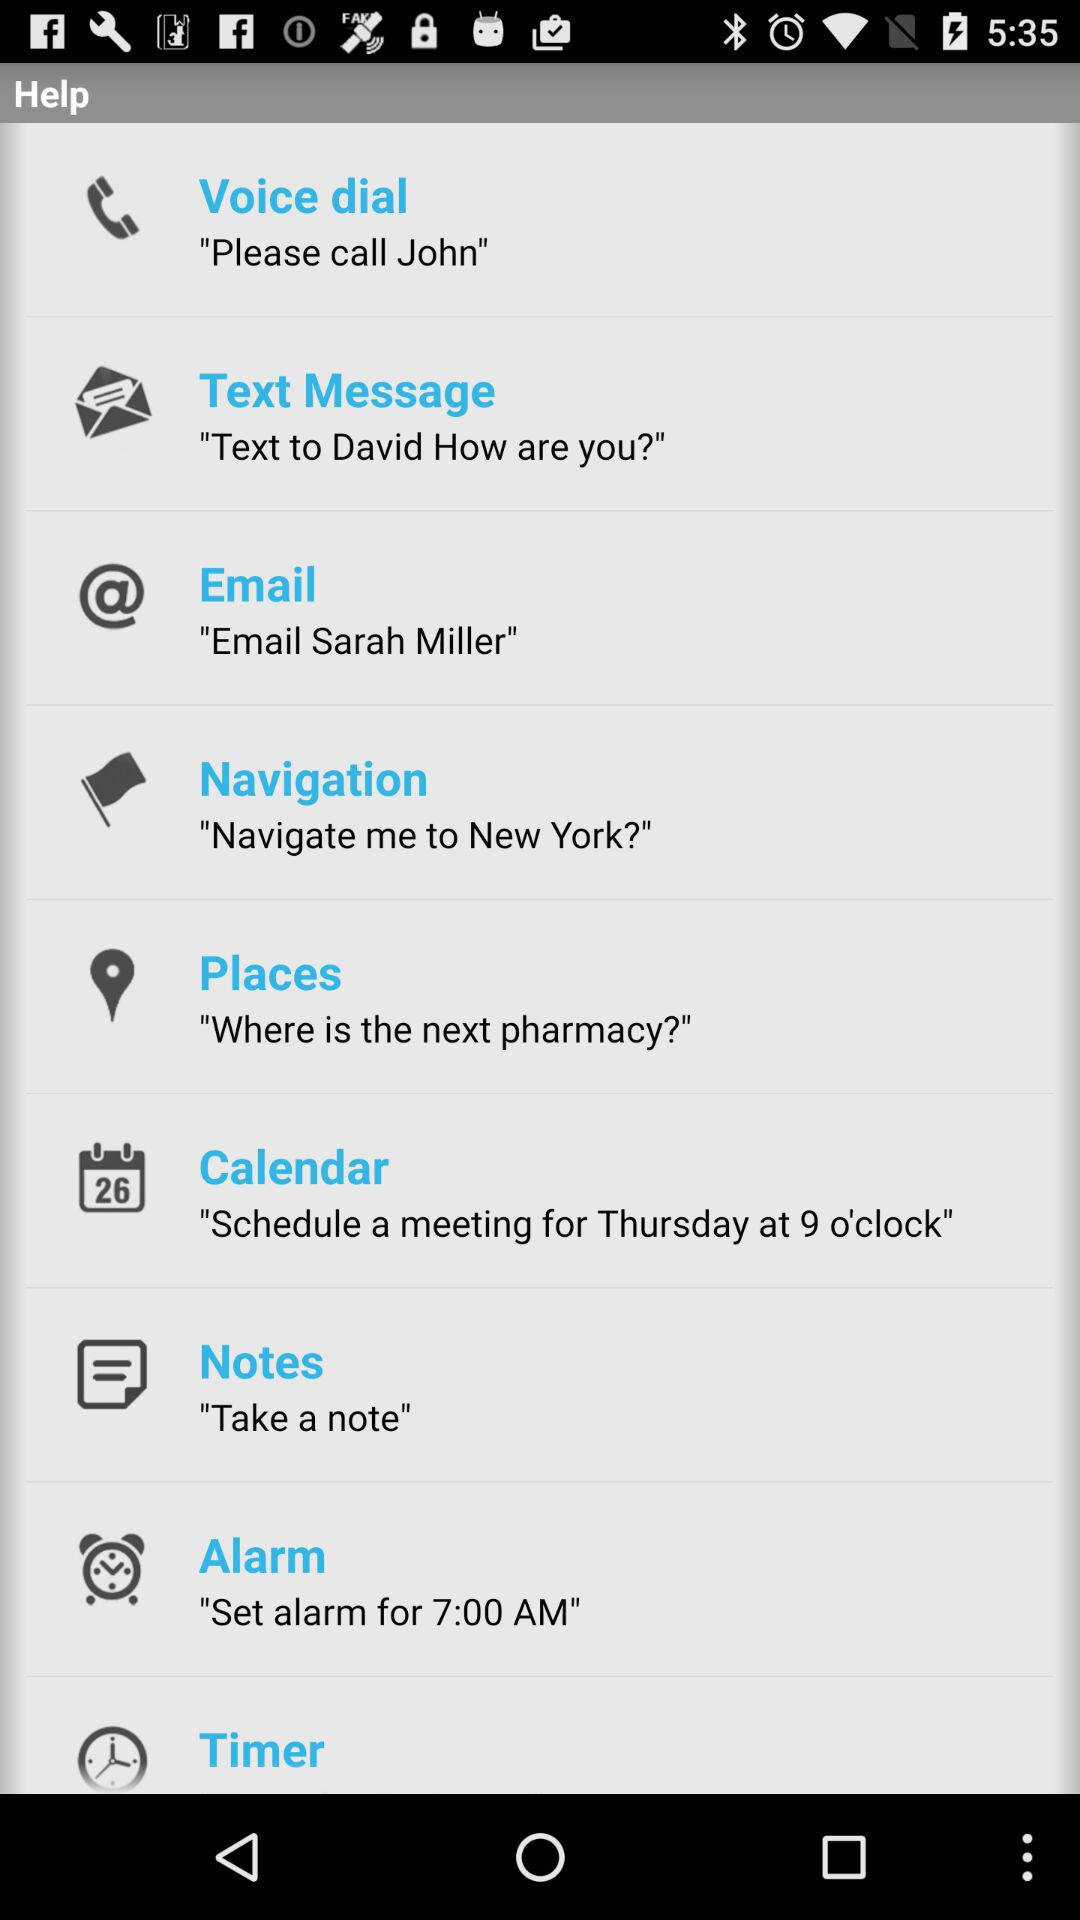What is the set alarm time? The set alarm time is 7:00 AM. 